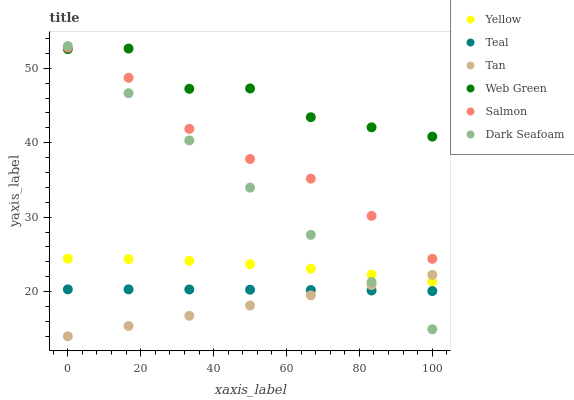Does Tan have the minimum area under the curve?
Answer yes or no. Yes. Does Web Green have the maximum area under the curve?
Answer yes or no. Yes. Does Dark Seafoam have the minimum area under the curve?
Answer yes or no. No. Does Dark Seafoam have the maximum area under the curve?
Answer yes or no. No. Is Tan the smoothest?
Answer yes or no. Yes. Is Web Green the roughest?
Answer yes or no. Yes. Is Dark Seafoam the smoothest?
Answer yes or no. No. Is Dark Seafoam the roughest?
Answer yes or no. No. Does Tan have the lowest value?
Answer yes or no. Yes. Does Dark Seafoam have the lowest value?
Answer yes or no. No. Does Dark Seafoam have the highest value?
Answer yes or no. Yes. Does Web Green have the highest value?
Answer yes or no. No. Is Teal less than Salmon?
Answer yes or no. Yes. Is Yellow greater than Teal?
Answer yes or no. Yes. Does Web Green intersect Salmon?
Answer yes or no. Yes. Is Web Green less than Salmon?
Answer yes or no. No. Is Web Green greater than Salmon?
Answer yes or no. No. Does Teal intersect Salmon?
Answer yes or no. No. 